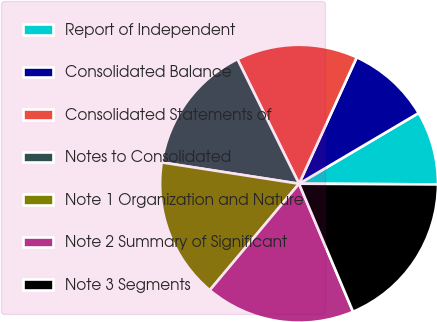Convert chart to OTSL. <chart><loc_0><loc_0><loc_500><loc_500><pie_chart><fcel>Report of Independent<fcel>Consolidated Balance<fcel>Consolidated Statements of<fcel>Notes to Consolidated<fcel>Note 1 Organization and Nature<fcel>Note 2 Summary of Significant<fcel>Note 3 Segments<nl><fcel>8.58%<fcel>9.69%<fcel>14.13%<fcel>15.24%<fcel>16.35%<fcel>17.46%<fcel>18.57%<nl></chart> 